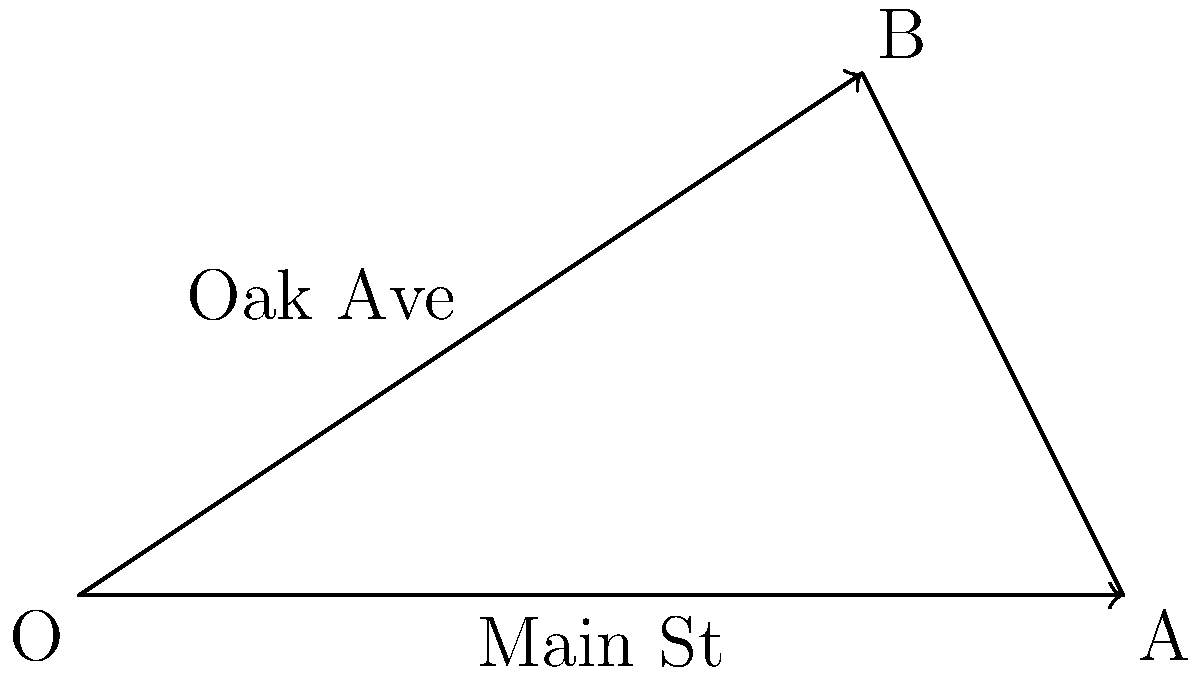As part of your job at the recruitment firm, you're creating a map for a new job listing. The office is located at the intersection of Main St and Oak Ave. On your coordinate system, Main St runs along the x-axis from O(0,0) to A(4,0), while Oak Ave runs from O(0,0) to B(3,2). What is the angle between Main St and Oak Ave? To find the angle between the two streets, we can use the dot product formula for vectors. Let's approach this step-by-step:

1. Define the vectors for Main St and Oak Ave:
   Main St vector: $\vec{v} = \overrightarrow{OA} = (4,0)$
   Oak Ave vector: $\vec{w} = \overrightarrow{OB} = (3,2)$

2. The formula for the angle $\theta$ between two vectors is:
   $\cos \theta = \frac{\vec{v} \cdot \vec{w}}{|\vec{v}||\vec{w}|}$

3. Calculate the dot product $\vec{v} \cdot \vec{w}$:
   $\vec{v} \cdot \vec{w} = (4)(3) + (0)(2) = 12$

4. Calculate the magnitudes:
   $|\vec{v}| = \sqrt{4^2 + 0^2} = 4$
   $|\vec{w}| = \sqrt{3^2 + 2^2} = \sqrt{13}$

5. Substitute into the formula:
   $\cos \theta = \frac{12}{4\sqrt{13}}$

6. Take the inverse cosine (arccos) of both sides:
   $\theta = \arccos(\frac{12}{4\sqrt{13}})$

7. Calculate the result:
   $\theta \approx 0.5880$ radians

8. Convert to degrees:
   $\theta \approx 0.5880 \times \frac{180}{\pi} \approx 33.69°$
Answer: $33.69°$ 